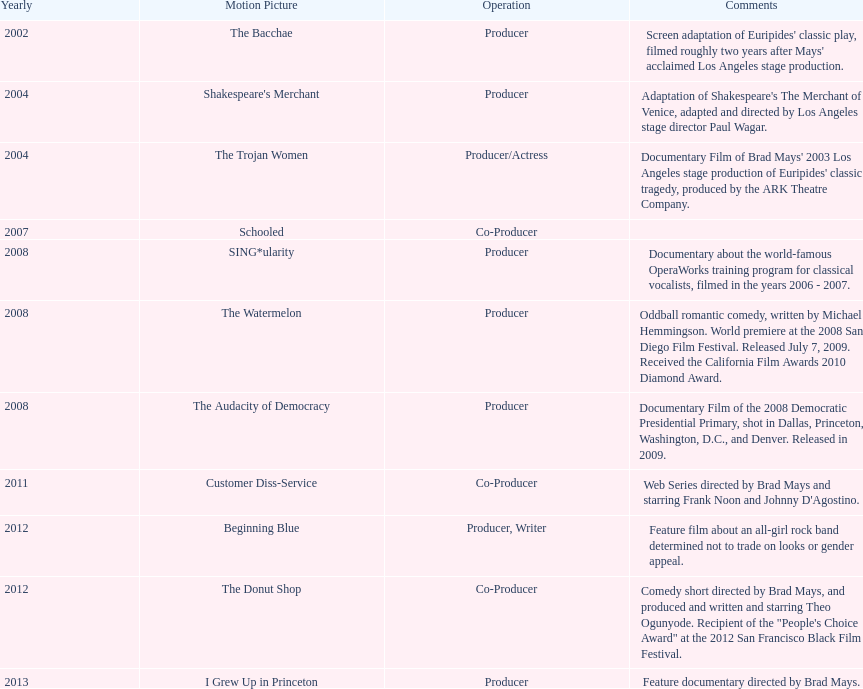What documentary film was produced before the year 2011 but after 2008? The Audacity of Democracy. 